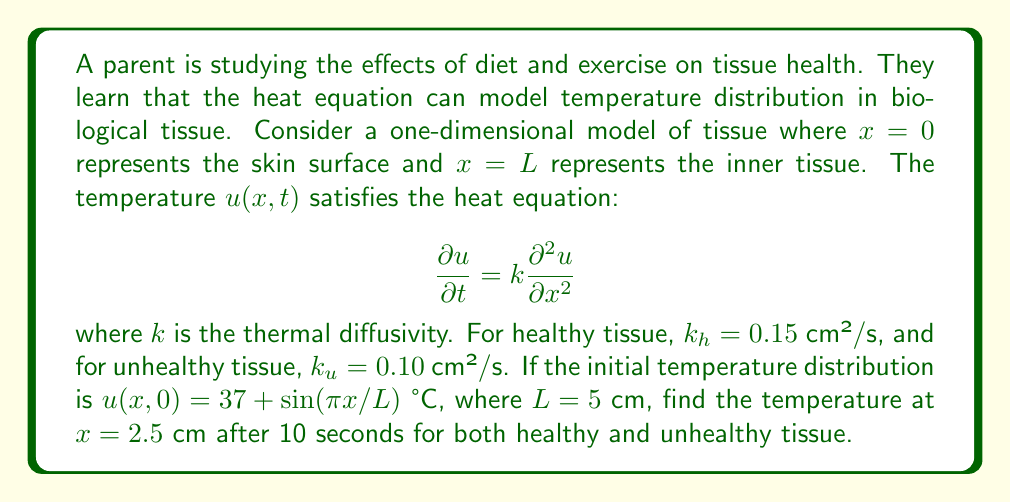Can you solve this math problem? To solve this problem, we'll use the separation of variables method for the heat equation:

1) The general solution for the heat equation with the given initial condition is:

   $$u(x,t) = 37 + e^{-k(\pi/L)^2t}\sin(\pi x/L)$$

2) We need to evaluate this at $x=2.5$ cm and $t=10$ s for both $k_h$ and $k_u$:

   For healthy tissue:
   $$u_h(2.5,10) = 37 + e^{-0.15(\pi/5)^2 \cdot 10}\sin(\pi \cdot 2.5/5)$$

   For unhealthy tissue:
   $$u_u(2.5,10) = 37 + e^{-0.10(\pi/5)^2 \cdot 10}\sin(\pi \cdot 2.5/5)$$

3) Simplify $\sin(\pi \cdot 2.5/5) = \sin(\pi/2) = 1$

4) Calculate the exponents:
   Healthy: $-0.15(\pi/5)^2 \cdot 10 = -0.5924$
   Unhealthy: $-0.10(\pi/5)^2 \cdot 10 = -0.3949$

5) Evaluate:
   $$u_h(2.5,10) = 37 + e^{-0.5924} = 37 + 0.5529 = 37.5529$$
   $$u_u(2.5,10) = 37 + e^{-0.3949} = 37 + 0.6737 = 37.6737$$

6) Round to two decimal places:
   $$u_h(2.5,10) \approx 37.55 \text{ °C}$$
   $$u_u(2.5,10) \approx 37.67 \text{ °C}$$
Answer: Healthy tissue: 37.55 °C, Unhealthy tissue: 37.67 °C 